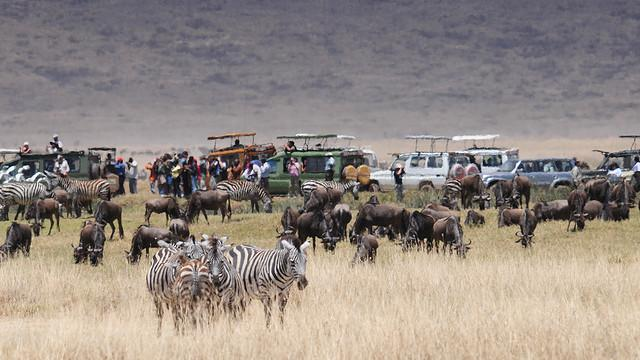What kind of animals are these in relation to their diets?

Choices:
A) nonmajors
B) omnivores
C) carnivores
D) herbivores herbivores 